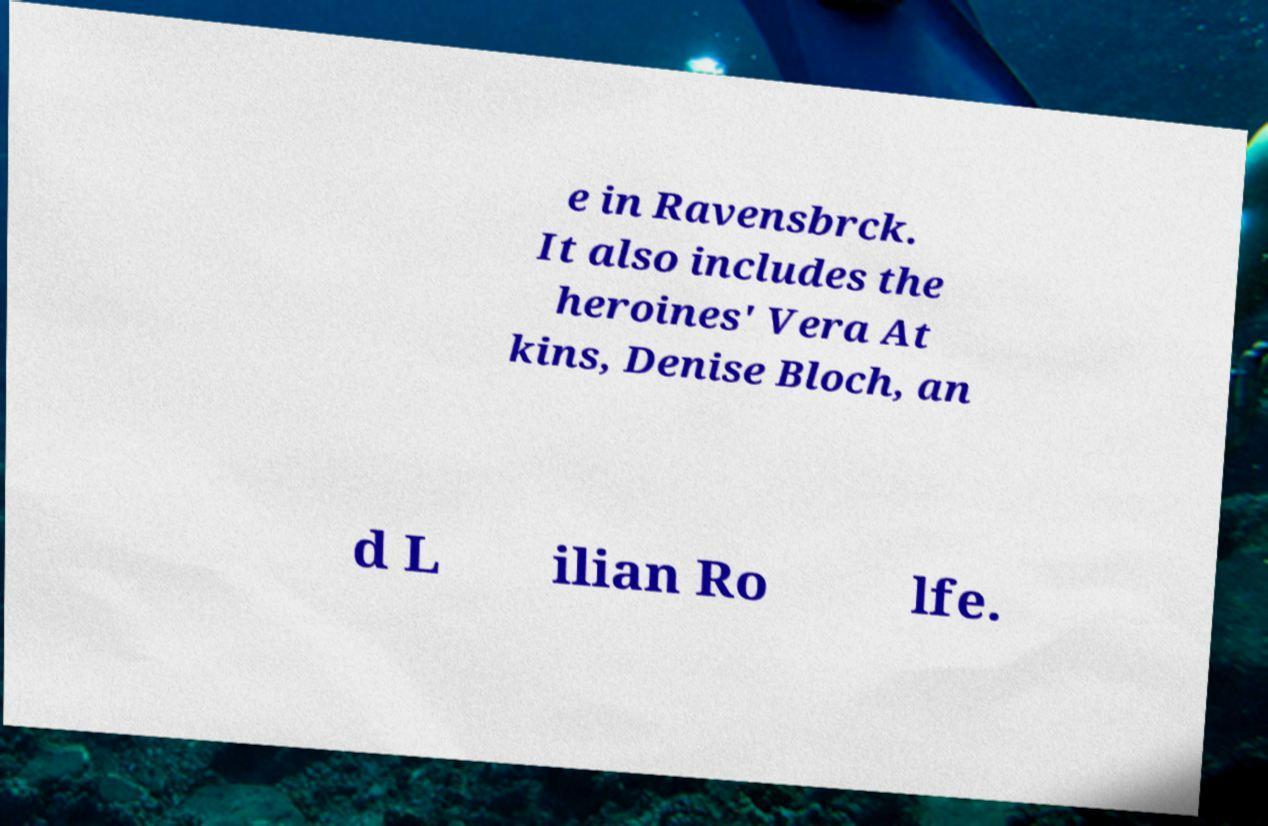What messages or text are displayed in this image? I need them in a readable, typed format. e in Ravensbrck. It also includes the heroines' Vera At kins, Denise Bloch, an d L ilian Ro lfe. 